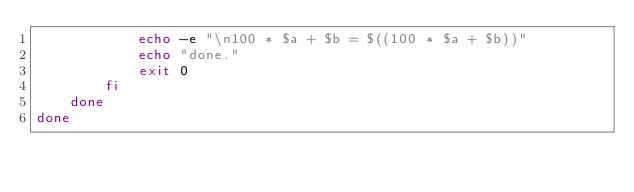<code> <loc_0><loc_0><loc_500><loc_500><_Bash_>			echo -e "\n100 * $a + $b = $((100 * $a + $b))"
			echo "done."
			exit 0
		fi
	done
done
</code> 